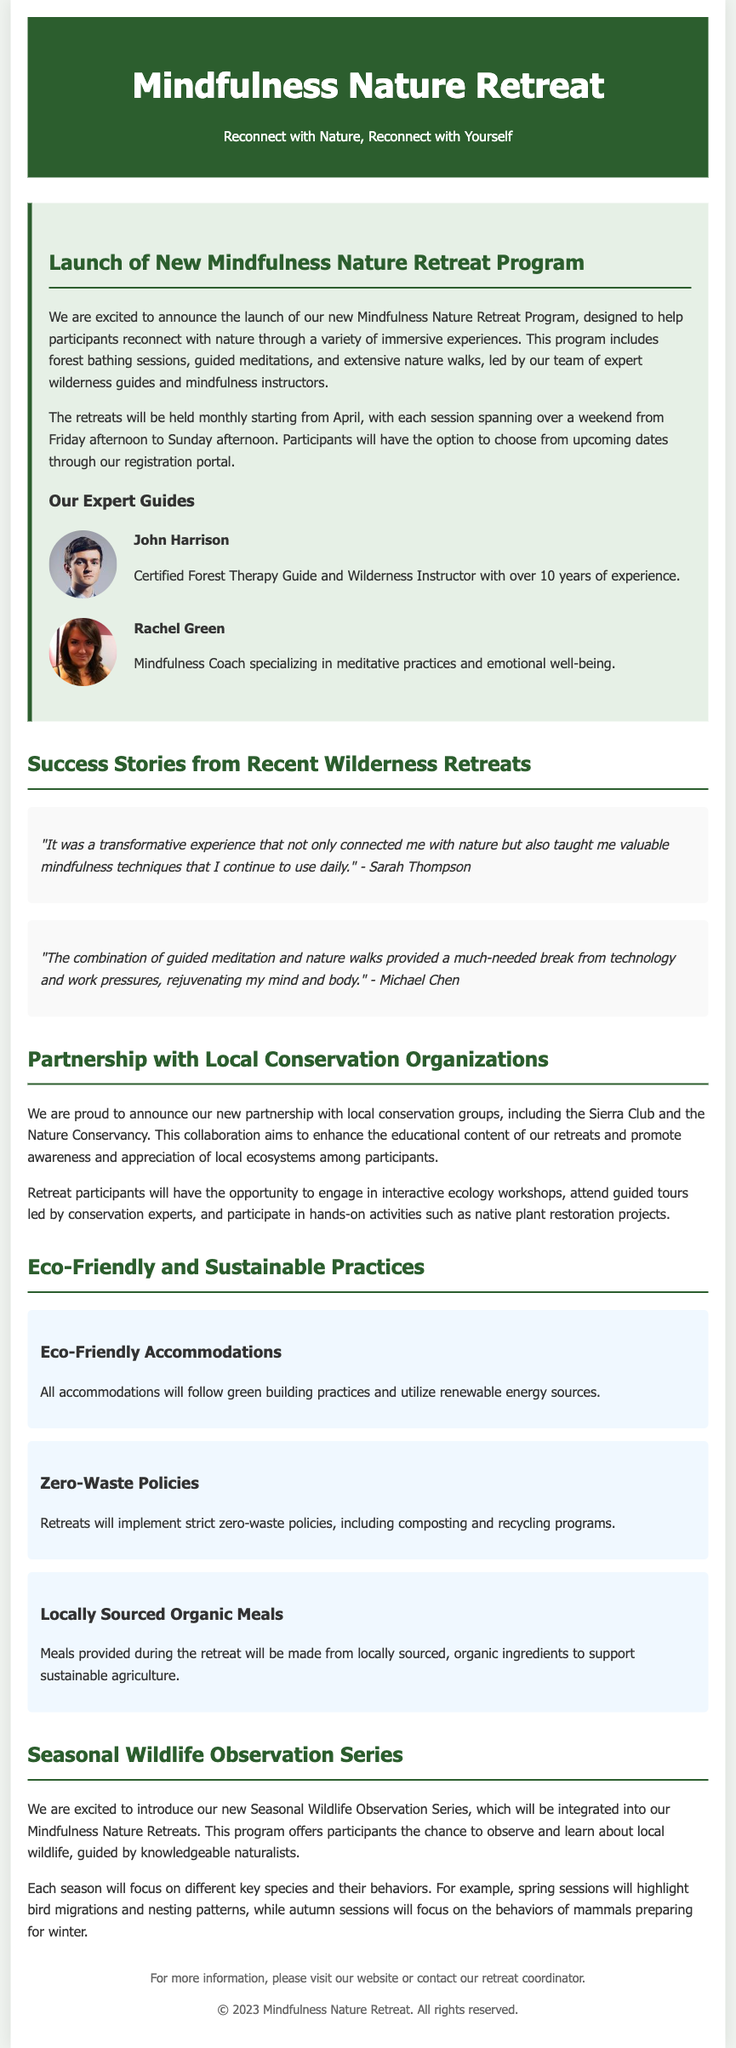What is the title of the retreat program? The title of the retreat program is mentioned in the first section of the document.
Answer: Mindfulness Nature Retreat Program When will the retreats start? The document specifies when the retreats will begin, noting the starting month.
Answer: April How many expert guides are mentioned? The document provides information about the number of expert guides highlighted in the retreats.
Answer: Two Which conservation organizations are mentioned in the partnership? The document lists specific conservation organizations collaborating with the retreat program, found in the relevant section.
Answer: Sierra Club, Nature Conservancy What kind of meals will be served at the retreats? The document describes the type of meals that will be provided, specifically focusing on sourcing.
Answer: Locally sourced, organic meals What is a key focus of the spring wildlife observation sessions? The document indicates what wildlife aspect participants will observe during the spring season, emphasizing a particular behavior.
Answer: Bird migrations What type of workshop will participants engage in during the retreats? The document mentions the type of educational workshops participants can expect to be involved with during the retreats.
Answer: Interactive ecology workshops What policy will the retreats implement for waste management? The document outlines a specific policy regarding waste management during the retreats.
Answer: Zero-waste policies 